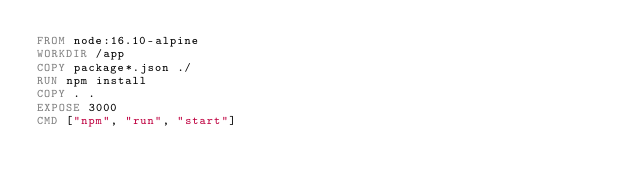Convert code to text. <code><loc_0><loc_0><loc_500><loc_500><_Dockerfile_>FROM node:16.10-alpine
WORKDIR /app
COPY package*.json ./
RUN npm install
COPY . .
EXPOSE 3000
CMD ["npm", "run", "start"]</code> 